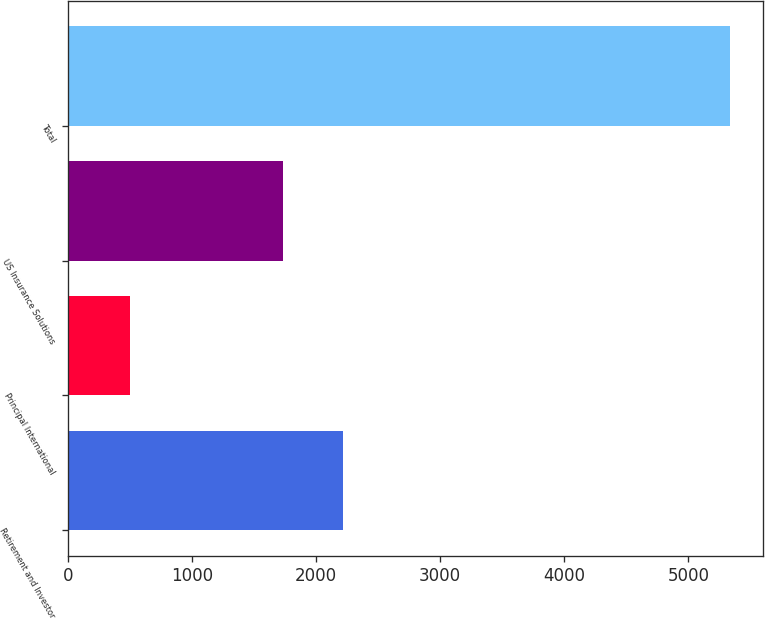Convert chart to OTSL. <chart><loc_0><loc_0><loc_500><loc_500><bar_chart><fcel>Retirement and Investor<fcel>Principal International<fcel>US Insurance Solutions<fcel>Total<nl><fcel>2218.37<fcel>497.7<fcel>1734.3<fcel>5338.4<nl></chart> 